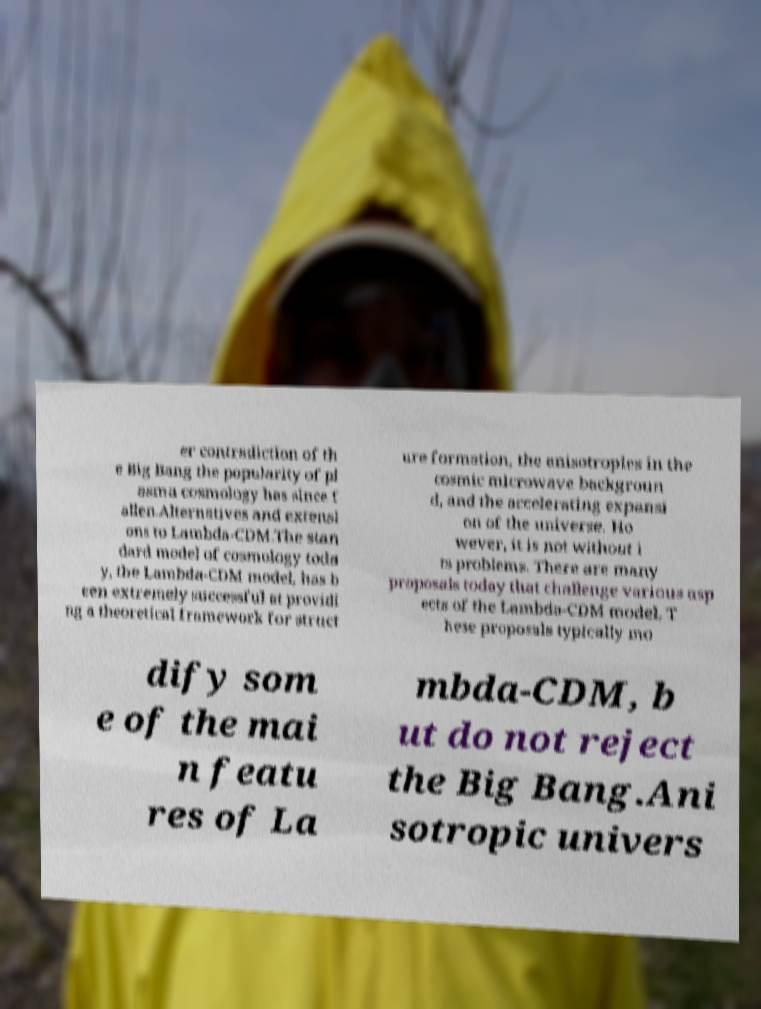There's text embedded in this image that I need extracted. Can you transcribe it verbatim? er contradiction of th e Big Bang the popularity of pl asma cosmology has since f allen.Alternatives and extensi ons to Lambda-CDM.The stan dard model of cosmology toda y, the Lambda-CDM model, has b een extremely successful at providi ng a theoretical framework for struct ure formation, the anisotropies in the cosmic microwave backgroun d, and the accelerating expansi on of the universe. Ho wever, it is not without i ts problems. There are many proposals today that challenge various asp ects of the Lambda-CDM model. T hese proposals typically mo dify som e of the mai n featu res of La mbda-CDM, b ut do not reject the Big Bang.Ani sotropic univers 